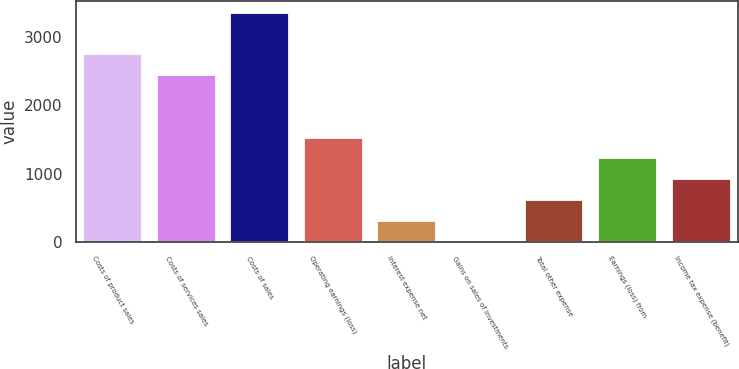Convert chart to OTSL. <chart><loc_0><loc_0><loc_500><loc_500><bar_chart><fcel>Costs of product sales<fcel>Costs of services sales<fcel>Costs of sales<fcel>Operating earnings (loss)<fcel>Interest expense net<fcel>Gains on sales of investments<fcel>Total other expense<fcel>Earnings (loss) from<fcel>Income tax expense (benefit)<nl><fcel>2745.5<fcel>2441<fcel>3354.5<fcel>1527.5<fcel>309.5<fcel>5<fcel>614<fcel>1223<fcel>918.5<nl></chart> 